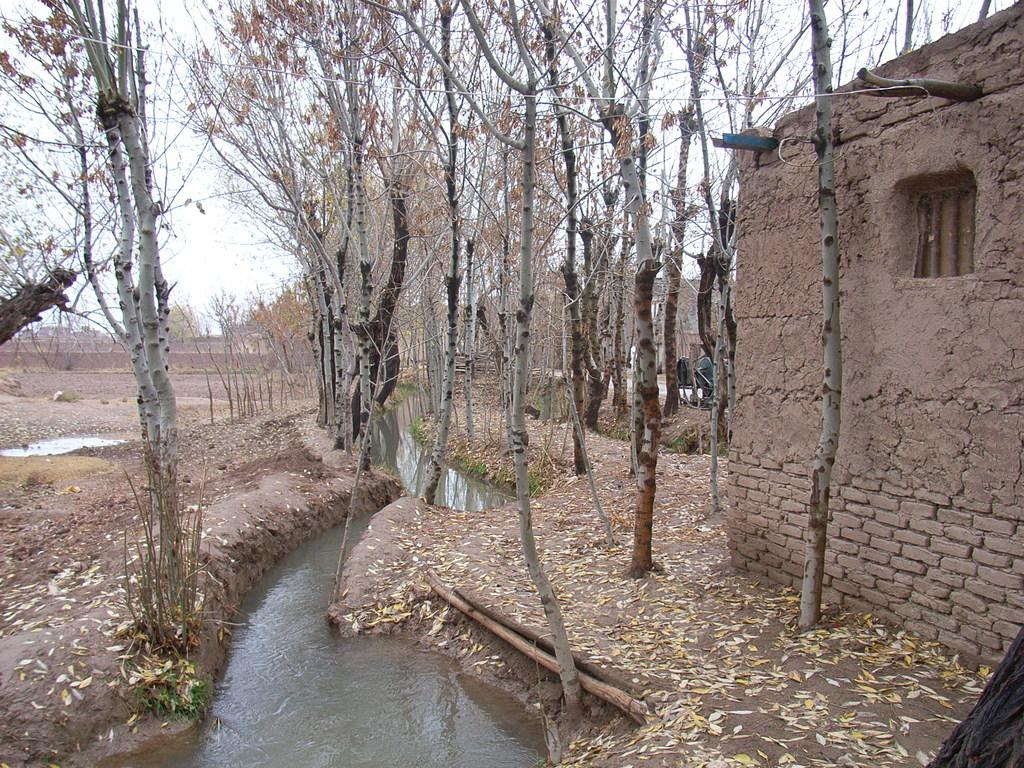What type of house is in the image? There is a brick house in the image. What other natural elements can be seen in the image? There are trees and water visible in the image. What might indicate the season or weather in the image? Dried leaves on the land suggest that it could be autumn or a dry season. What is visible in the background of the image? The sky is visible in the image. Where is the hospital located in the image? There is no hospital present in the image. What type of beast can be seen roaming near the brick house? There are no beasts present in the image; it features a brick house, trees, water, dried leaves, and the sky. 